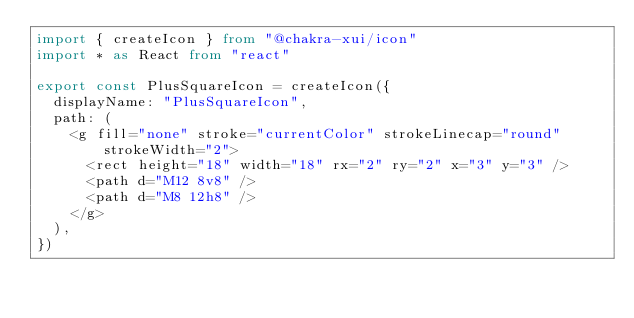<code> <loc_0><loc_0><loc_500><loc_500><_TypeScript_>import { createIcon } from "@chakra-xui/icon"
import * as React from "react"

export const PlusSquareIcon = createIcon({
  displayName: "PlusSquareIcon",
  path: (
    <g fill="none" stroke="currentColor" strokeLinecap="round" strokeWidth="2">
      <rect height="18" width="18" rx="2" ry="2" x="3" y="3" />
      <path d="M12 8v8" />
      <path d="M8 12h8" />
    </g>
  ),
})
</code> 